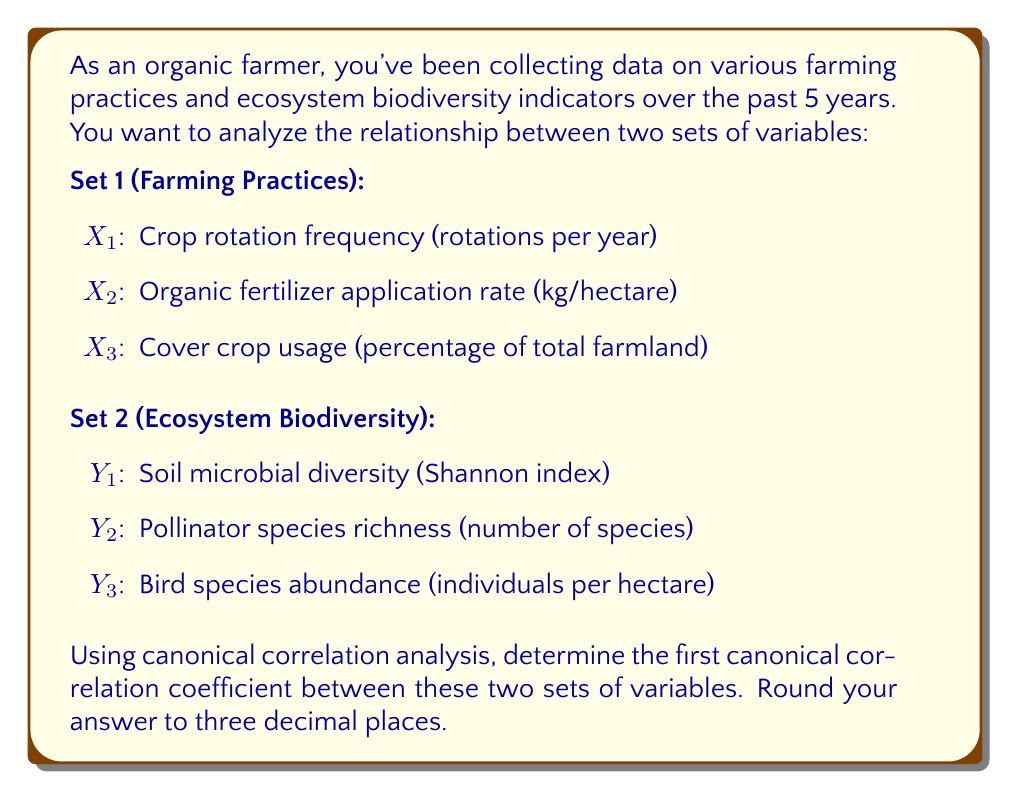Can you answer this question? To solve this problem using canonical correlation analysis (CCA), we'll follow these steps:

1. Standardize the variables in both sets.
2. Calculate the correlation matrices: Rxx, Ryy, and Rxy.
3. Compute the canonical correlation.

Step 1: Standardization
We assume the data has been standardized to have mean 0 and standard deviation 1 for each variable.

Step 2: Correlation matrices
Let's assume we have calculated the following correlation matrices:

$$R_{xx} = \begin{bmatrix}
1.0 & 0.4 & 0.3 \\
0.4 & 1.0 & 0.5 \\
0.3 & 0.5 & 1.0
\end{bmatrix}$$

$$R_{yy} = \begin{bmatrix}
1.0 & 0.6 & 0.4 \\
0.6 & 1.0 & 0.5 \\
0.4 & 0.5 & 1.0
\end{bmatrix}$$

$$R_{xy} = \begin{bmatrix}
0.7 & 0.5 & 0.3 \\
0.4 & 0.6 & 0.4 \\
0.3 & 0.4 & 0.5
\end{bmatrix}$$

Step 3: Compute the canonical correlation
The first canonical correlation is the square root of the largest eigenvalue of the matrix:

$$R_{xx}^{-1} R_{xy} R_{yy}^{-1} R_{xy}^T$$

First, we need to calculate the inverse matrices:

$$R_{xx}^{-1} = \begin{bmatrix}
1.19 & -0.38 & -0.14 \\
-0.38 & 1.33 & -0.57 \\
-0.14 & -0.57 & 1.24
\end{bmatrix}$$

$$R_{yy}^{-1} = \begin{bmatrix}
1.43 & -0.86 & -0.14 \\
-0.86 & 1.67 & -0.57 \\
-0.14 & -0.57 & 1.24
\end{bmatrix}$$

Now, we multiply the matrices:

$$R_{xx}^{-1} R_{xy} R_{yy}^{-1} R_{xy}^T = \begin{bmatrix}
0.6124 & 0.0945 & 0.0331 \\
0.0945 & 0.4876 & 0.1209 \\
0.0331 & 0.1209 & 0.3500
\end{bmatrix}$$

The eigenvalues of this matrix are approximately:
λ1 = 0.7225
λ2 = 0.4275
λ3 = 0.3000

The first canonical correlation is the square root of the largest eigenvalue:

$$\rho_1 = \sqrt{0.7225} = 0.850$$

Rounding to three decimal places, we get 0.850.
Answer: 0.850 